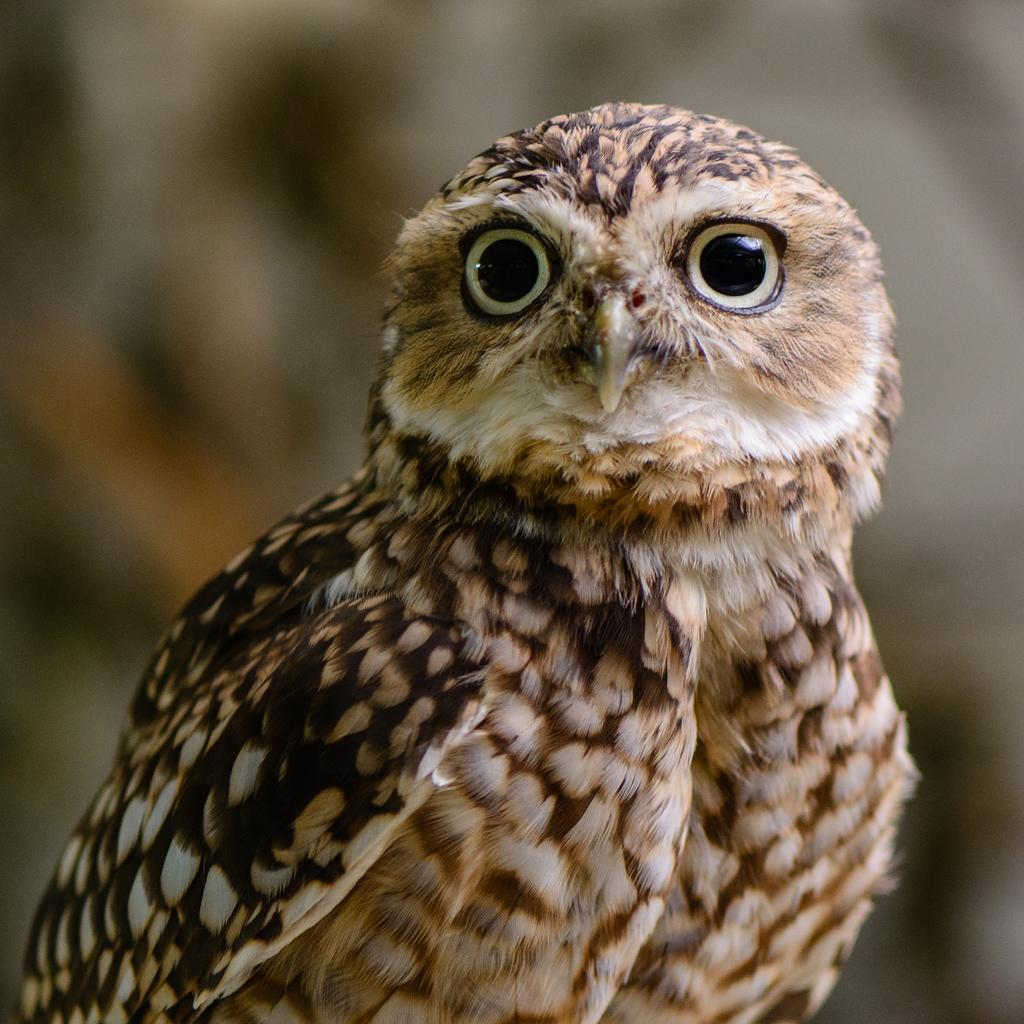What animal is in the foreground of the image? There is an owl in the foreground of the image. What can be observed about the background of the image? The background of the image is blurred. What type of representative is present in the image? There is no representative present in the image; it features an owl in the foreground and a blurred background. What is the owl doing with its mouth in the image? The image does not show the owl's mouth or any action related to it. 